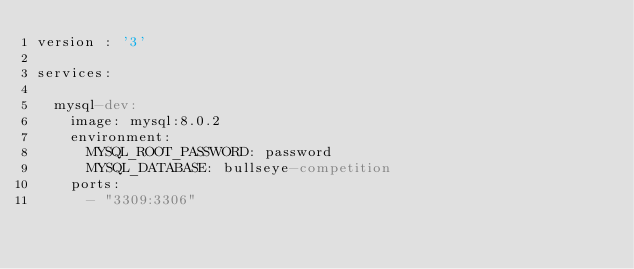<code> <loc_0><loc_0><loc_500><loc_500><_YAML_>version : '3'

services:

  mysql-dev:
    image: mysql:8.0.2
    environment:
      MYSQL_ROOT_PASSWORD: password
      MYSQL_DATABASE: bullseye-competition
    ports:
      - "3309:3306"</code> 